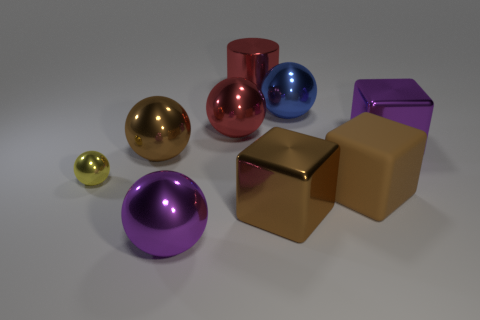There is a thing that is to the left of the large blue metal object and behind the large red ball; how big is it?
Offer a terse response. Large. The big purple thing that is to the right of the large purple metallic object in front of the large purple metallic cube is what shape?
Provide a short and direct response. Cube. Is there anything else that is the same shape as the big blue shiny thing?
Your response must be concise. Yes. Is the number of big brown metal balls that are on the left side of the tiny shiny thing the same as the number of large red objects?
Your answer should be compact. No. There is a tiny sphere; is it the same color as the sphere right of the big metallic cylinder?
Provide a short and direct response. No. There is a thing that is both on the right side of the blue metallic sphere and in front of the yellow metallic object; what is its color?
Offer a terse response. Brown. There is a brown metallic object that is on the right side of the large purple ball; what number of red spheres are in front of it?
Your answer should be very brief. 0. Is there another metal object of the same shape as the tiny shiny object?
Keep it short and to the point. Yes. There is a big red metallic object that is in front of the large blue ball; is its shape the same as the purple object on the left side of the purple metal cube?
Provide a short and direct response. Yes. How many objects are either blue metallic balls or large metallic balls?
Offer a very short reply. 4. 